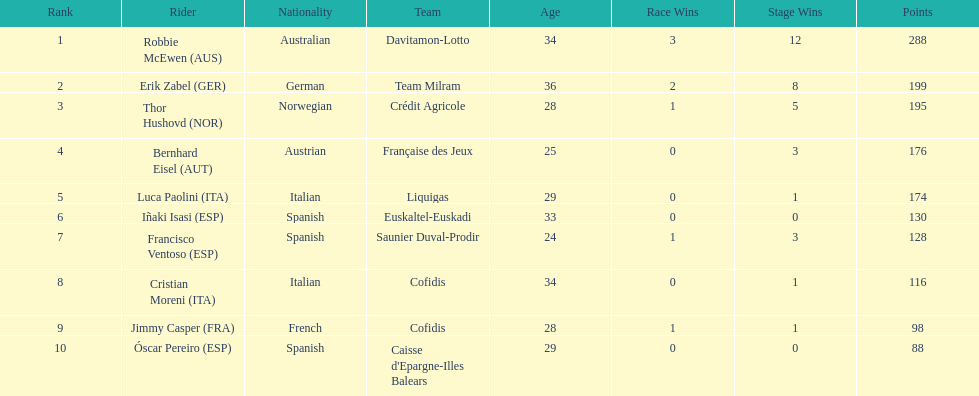How many points did robbie mcewen and cristian moreni score together? 404. 